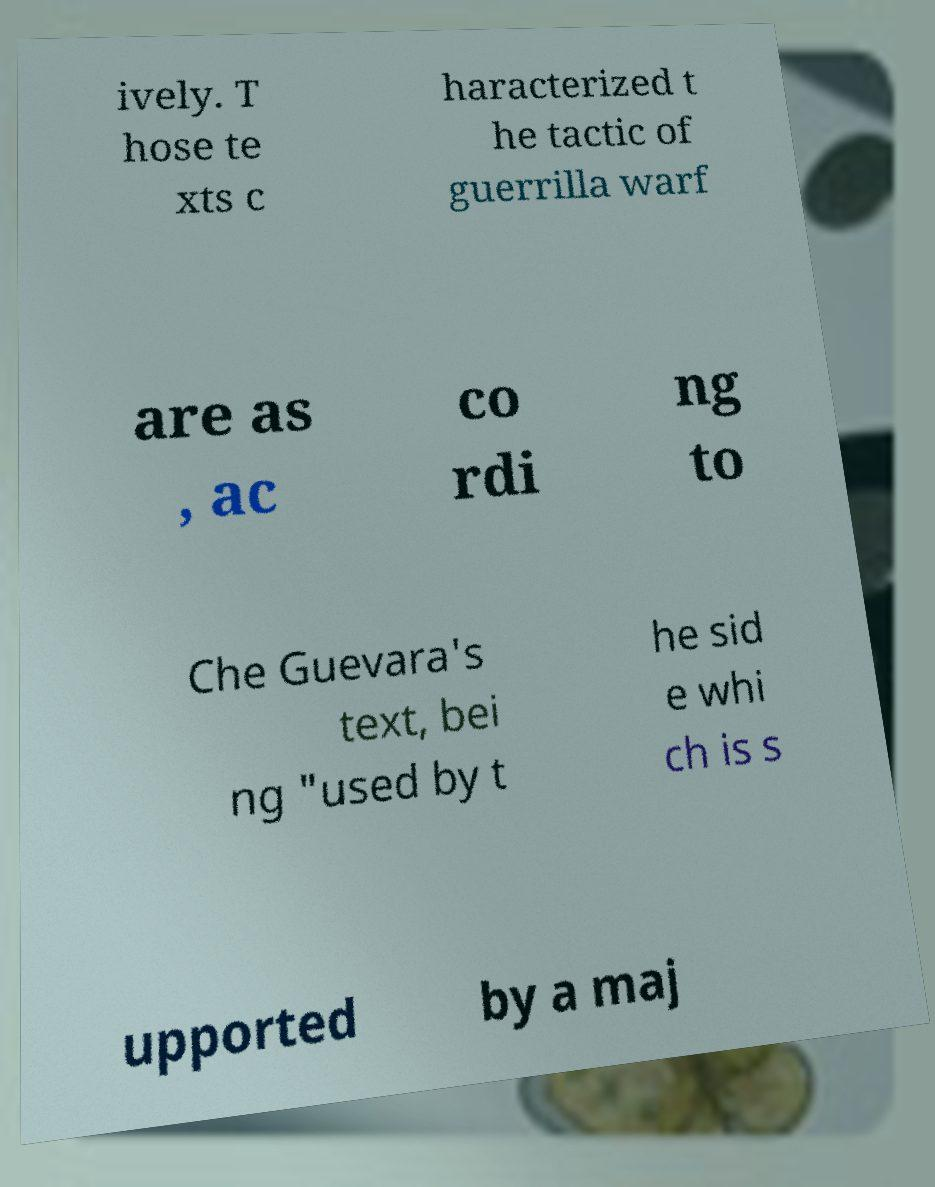What messages or text are displayed in this image? I need them in a readable, typed format. ively. T hose te xts c haracterized t he tactic of guerrilla warf are as , ac co rdi ng to Che Guevara's text, bei ng "used by t he sid e whi ch is s upported by a maj 